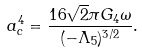<formula> <loc_0><loc_0><loc_500><loc_500>a ^ { 4 } _ { c } = \frac { 1 6 \sqrt { 2 } \pi G _ { 4 } \omega } { ( - \Lambda _ { 5 } ) ^ { 3 / 2 } } .</formula> 